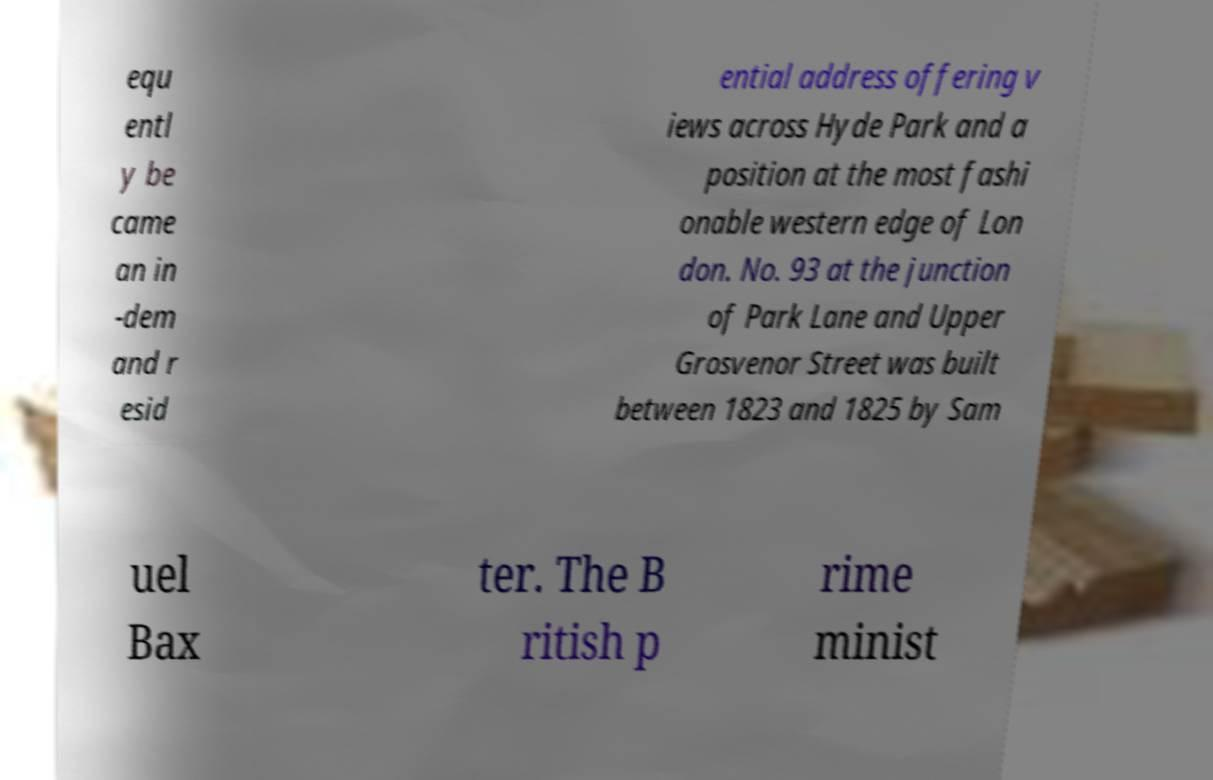Please read and relay the text visible in this image. What does it say? equ entl y be came an in -dem and r esid ential address offering v iews across Hyde Park and a position at the most fashi onable western edge of Lon don. No. 93 at the junction of Park Lane and Upper Grosvenor Street was built between 1823 and 1825 by Sam uel Bax ter. The B ritish p rime minist 